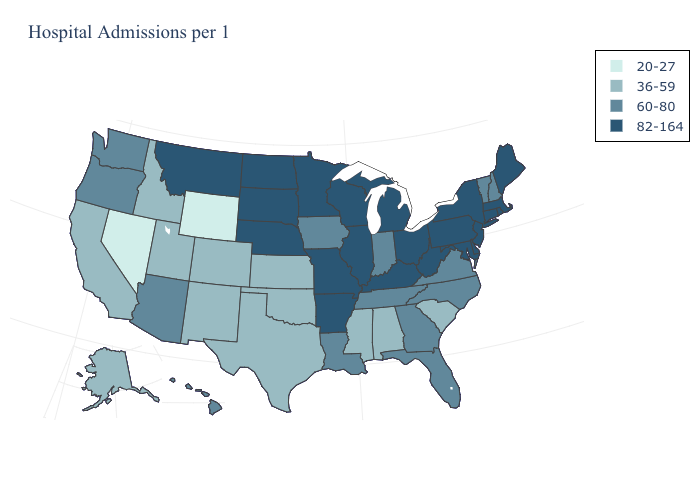Does Massachusetts have the highest value in the USA?
Give a very brief answer. Yes. Does Wyoming have the lowest value in the USA?
Be succinct. Yes. What is the lowest value in the MidWest?
Concise answer only. 36-59. Among the states that border Arkansas , does Louisiana have the highest value?
Quick response, please. No. Name the states that have a value in the range 36-59?
Concise answer only. Alabama, Alaska, California, Colorado, Idaho, Kansas, Mississippi, New Mexico, Oklahoma, South Carolina, Texas, Utah. Name the states that have a value in the range 82-164?
Concise answer only. Arkansas, Connecticut, Delaware, Illinois, Kentucky, Maine, Maryland, Massachusetts, Michigan, Minnesota, Missouri, Montana, Nebraska, New Jersey, New York, North Dakota, Ohio, Pennsylvania, Rhode Island, South Dakota, West Virginia, Wisconsin. Among the states that border South Dakota , does Wyoming have the highest value?
Answer briefly. No. Name the states that have a value in the range 20-27?
Answer briefly. Nevada, Wyoming. What is the value of South Dakota?
Answer briefly. 82-164. What is the highest value in states that border Nebraska?
Short answer required. 82-164. What is the lowest value in states that border Mississippi?
Concise answer only. 36-59. What is the value of Louisiana?
Answer briefly. 60-80. Name the states that have a value in the range 82-164?
Short answer required. Arkansas, Connecticut, Delaware, Illinois, Kentucky, Maine, Maryland, Massachusetts, Michigan, Minnesota, Missouri, Montana, Nebraska, New Jersey, New York, North Dakota, Ohio, Pennsylvania, Rhode Island, South Dakota, West Virginia, Wisconsin. Which states have the lowest value in the USA?
Be succinct. Nevada, Wyoming. What is the value of Nevada?
Be succinct. 20-27. 